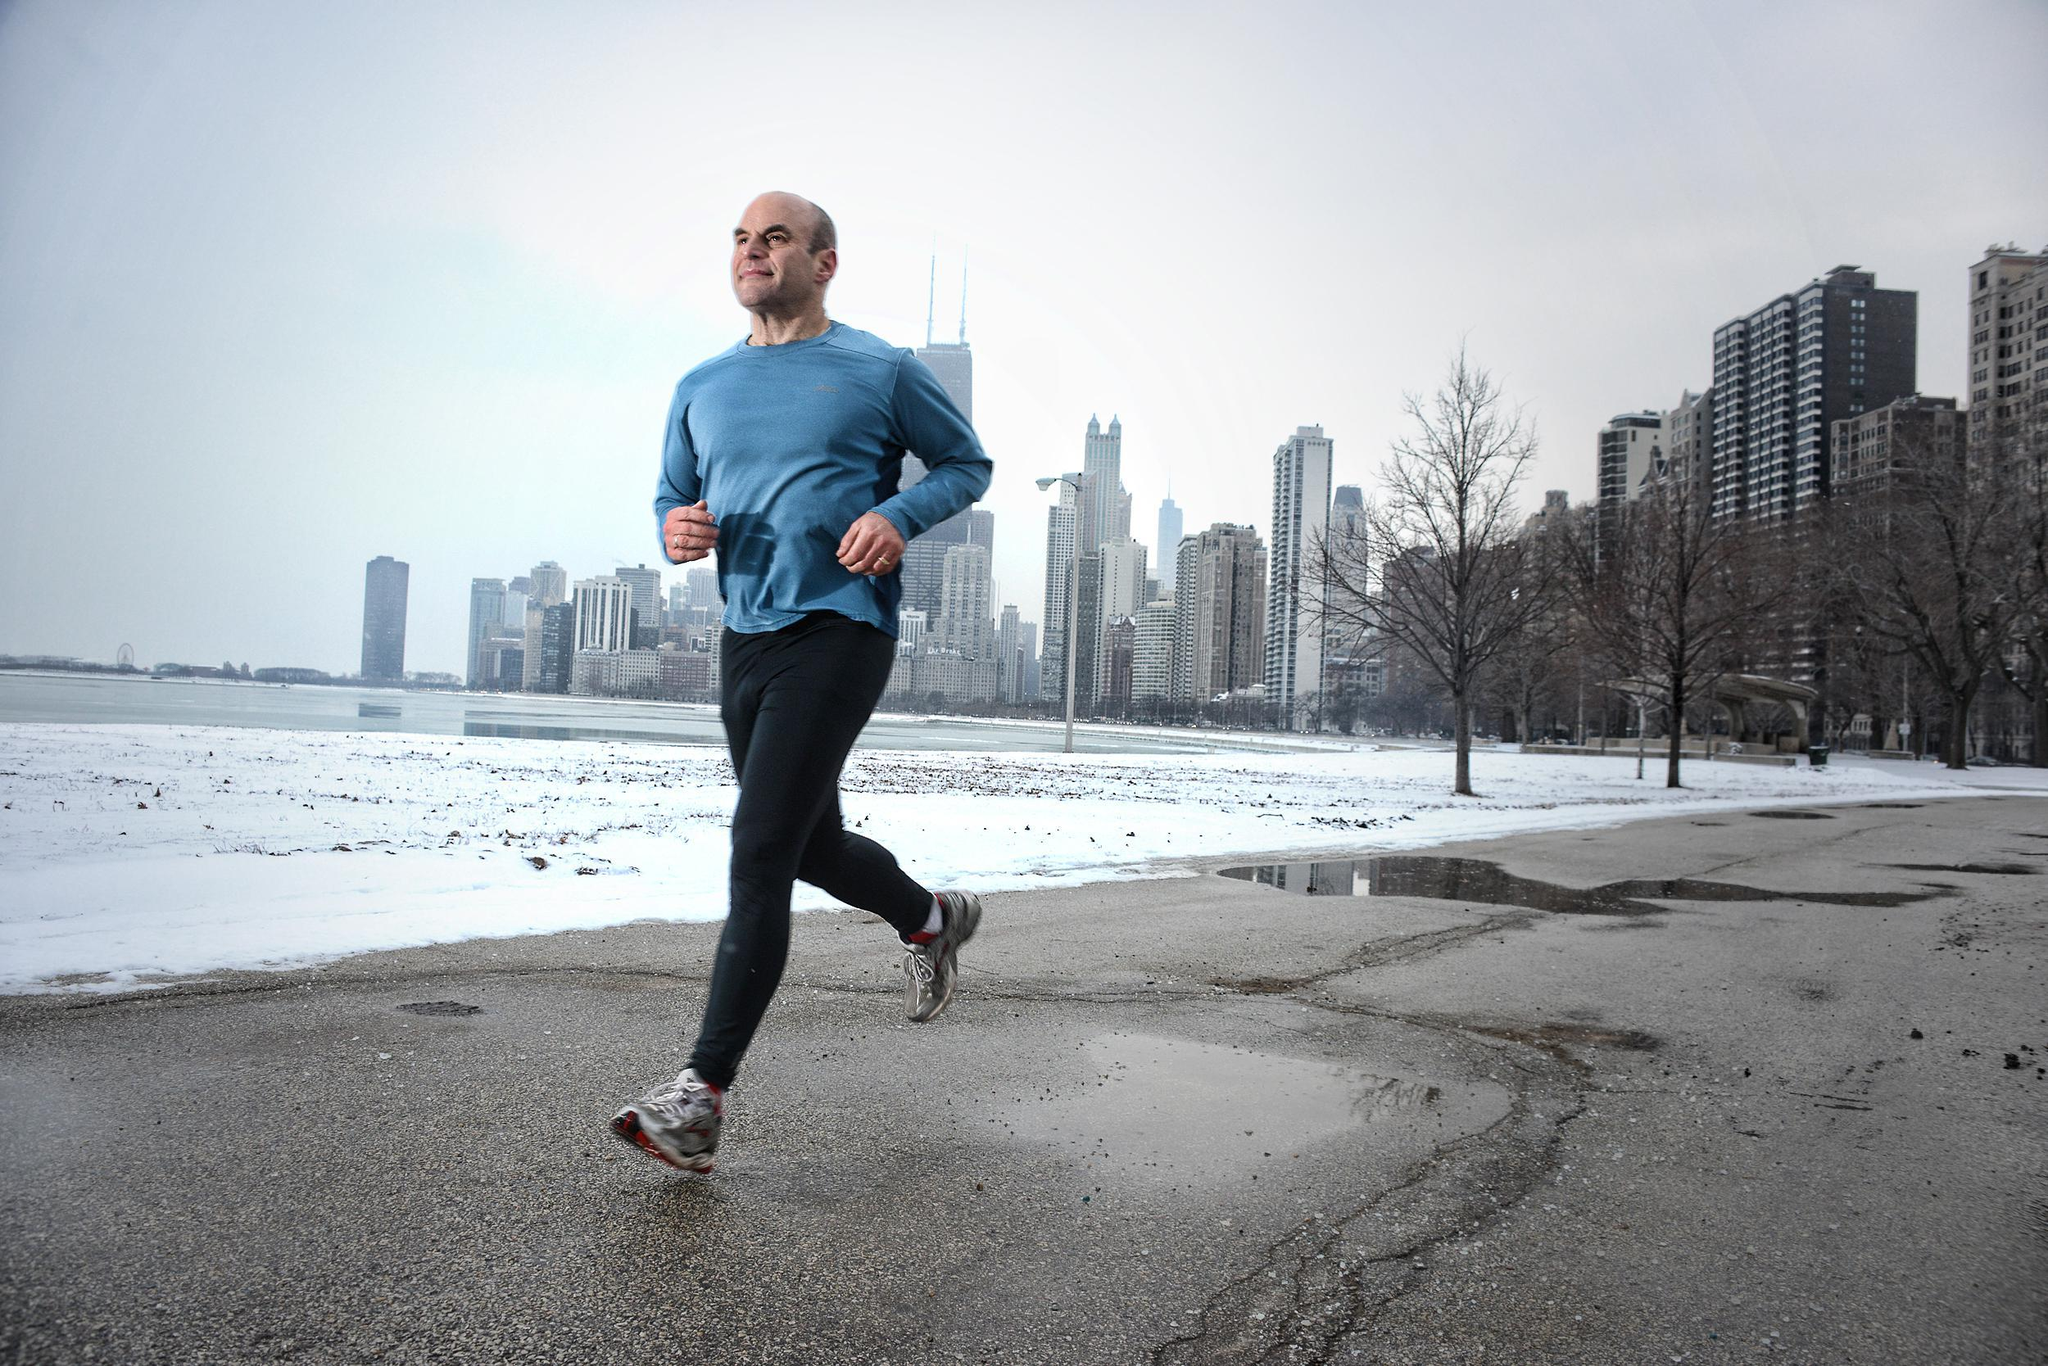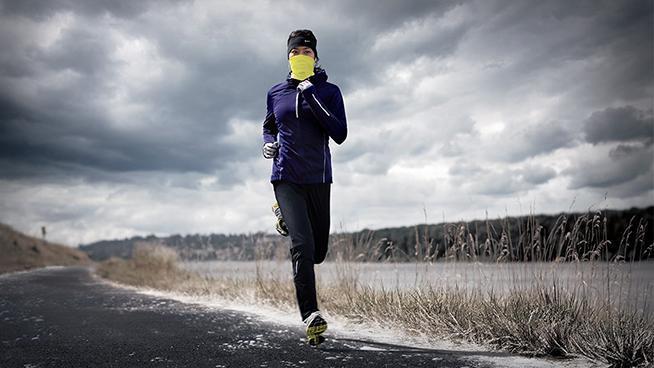The first image is the image on the left, the second image is the image on the right. Evaluate the accuracy of this statement regarding the images: "There are two people running on the pavement.". Is it true? Answer yes or no. Yes. The first image is the image on the left, the second image is the image on the right. Evaluate the accuracy of this statement regarding the images: "There is an image of a single shoe pointing to the right.". Is it true? Answer yes or no. No. 